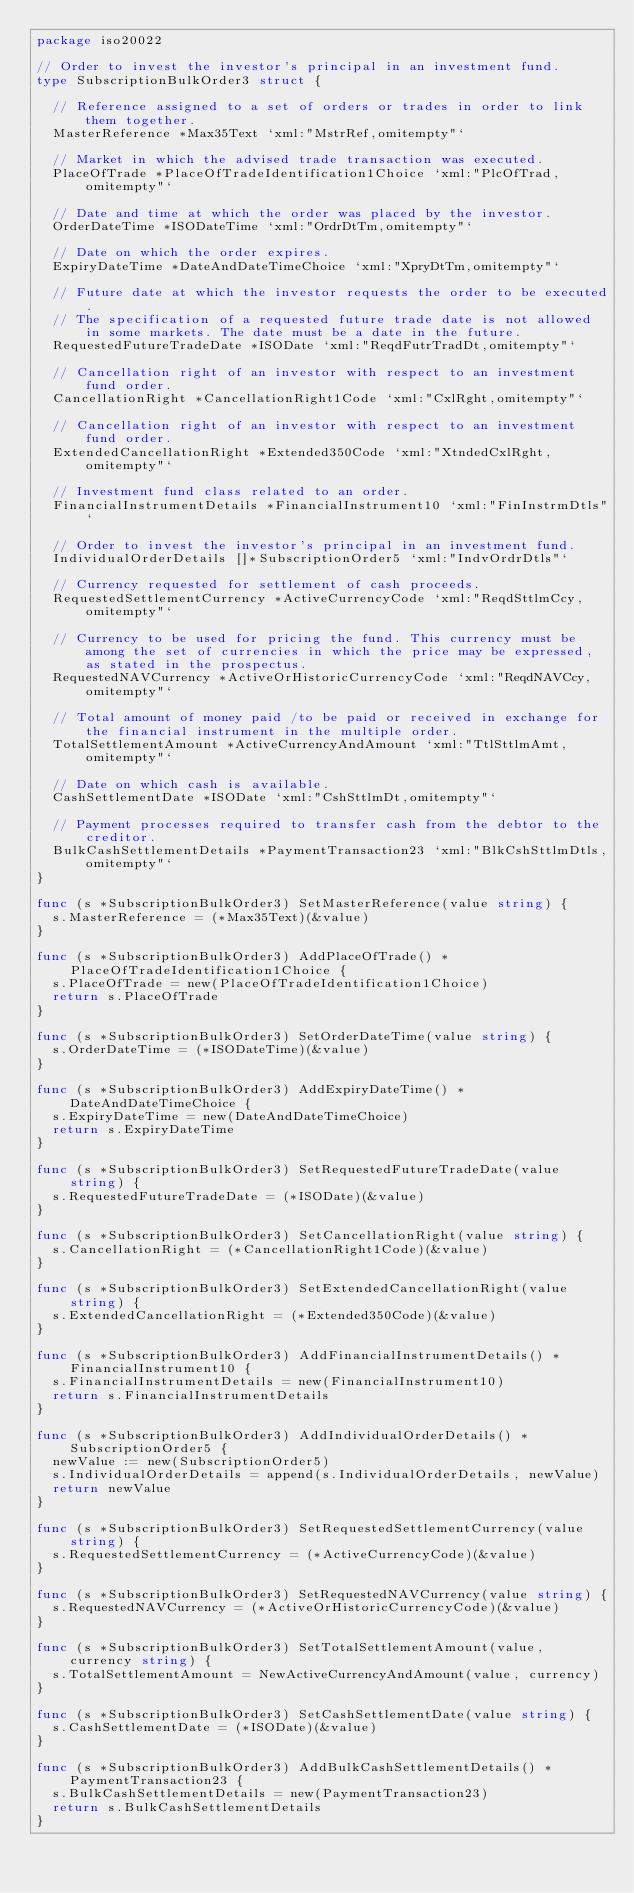<code> <loc_0><loc_0><loc_500><loc_500><_Go_>package iso20022

// Order to invest the investor's principal in an investment fund.
type SubscriptionBulkOrder3 struct {

	// Reference assigned to a set of orders or trades in order to link them together.
	MasterReference *Max35Text `xml:"MstrRef,omitempty"`

	// Market in which the advised trade transaction was executed.
	PlaceOfTrade *PlaceOfTradeIdentification1Choice `xml:"PlcOfTrad,omitempty"`

	// Date and time at which the order was placed by the investor.
	OrderDateTime *ISODateTime `xml:"OrdrDtTm,omitempty"`

	// Date on which the order expires.
	ExpiryDateTime *DateAndDateTimeChoice `xml:"XpryDtTm,omitempty"`

	// Future date at which the investor requests the order to be executed.
	// The specification of a requested future trade date is not allowed in some markets. The date must be a date in the future.
	RequestedFutureTradeDate *ISODate `xml:"ReqdFutrTradDt,omitempty"`

	// Cancellation right of an investor with respect to an investment fund order.
	CancellationRight *CancellationRight1Code `xml:"CxlRght,omitempty"`

	// Cancellation right of an investor with respect to an investment fund order.
	ExtendedCancellationRight *Extended350Code `xml:"XtndedCxlRght,omitempty"`

	// Investment fund class related to an order.
	FinancialInstrumentDetails *FinancialInstrument10 `xml:"FinInstrmDtls"`

	// Order to invest the investor's principal in an investment fund.
	IndividualOrderDetails []*SubscriptionOrder5 `xml:"IndvOrdrDtls"`

	// Currency requested for settlement of cash proceeds.
	RequestedSettlementCurrency *ActiveCurrencyCode `xml:"ReqdSttlmCcy,omitempty"`

	// Currency to be used for pricing the fund. This currency must be among the set of currencies in which the price may be expressed, as stated in the prospectus.
	RequestedNAVCurrency *ActiveOrHistoricCurrencyCode `xml:"ReqdNAVCcy,omitempty"`

	// Total amount of money paid /to be paid or received in exchange for the financial instrument in the multiple order.
	TotalSettlementAmount *ActiveCurrencyAndAmount `xml:"TtlSttlmAmt,omitempty"`

	// Date on which cash is available.
	CashSettlementDate *ISODate `xml:"CshSttlmDt,omitempty"`

	// Payment processes required to transfer cash from the debtor to the creditor.
	BulkCashSettlementDetails *PaymentTransaction23 `xml:"BlkCshSttlmDtls,omitempty"`
}

func (s *SubscriptionBulkOrder3) SetMasterReference(value string) {
	s.MasterReference = (*Max35Text)(&value)
}

func (s *SubscriptionBulkOrder3) AddPlaceOfTrade() *PlaceOfTradeIdentification1Choice {
	s.PlaceOfTrade = new(PlaceOfTradeIdentification1Choice)
	return s.PlaceOfTrade
}

func (s *SubscriptionBulkOrder3) SetOrderDateTime(value string) {
	s.OrderDateTime = (*ISODateTime)(&value)
}

func (s *SubscriptionBulkOrder3) AddExpiryDateTime() *DateAndDateTimeChoice {
	s.ExpiryDateTime = new(DateAndDateTimeChoice)
	return s.ExpiryDateTime
}

func (s *SubscriptionBulkOrder3) SetRequestedFutureTradeDate(value string) {
	s.RequestedFutureTradeDate = (*ISODate)(&value)
}

func (s *SubscriptionBulkOrder3) SetCancellationRight(value string) {
	s.CancellationRight = (*CancellationRight1Code)(&value)
}

func (s *SubscriptionBulkOrder3) SetExtendedCancellationRight(value string) {
	s.ExtendedCancellationRight = (*Extended350Code)(&value)
}

func (s *SubscriptionBulkOrder3) AddFinancialInstrumentDetails() *FinancialInstrument10 {
	s.FinancialInstrumentDetails = new(FinancialInstrument10)
	return s.FinancialInstrumentDetails
}

func (s *SubscriptionBulkOrder3) AddIndividualOrderDetails() *SubscriptionOrder5 {
	newValue := new(SubscriptionOrder5)
	s.IndividualOrderDetails = append(s.IndividualOrderDetails, newValue)
	return newValue
}

func (s *SubscriptionBulkOrder3) SetRequestedSettlementCurrency(value string) {
	s.RequestedSettlementCurrency = (*ActiveCurrencyCode)(&value)
}

func (s *SubscriptionBulkOrder3) SetRequestedNAVCurrency(value string) {
	s.RequestedNAVCurrency = (*ActiveOrHistoricCurrencyCode)(&value)
}

func (s *SubscriptionBulkOrder3) SetTotalSettlementAmount(value, currency string) {
	s.TotalSettlementAmount = NewActiveCurrencyAndAmount(value, currency)
}

func (s *SubscriptionBulkOrder3) SetCashSettlementDate(value string) {
	s.CashSettlementDate = (*ISODate)(&value)
}

func (s *SubscriptionBulkOrder3) AddBulkCashSettlementDetails() *PaymentTransaction23 {
	s.BulkCashSettlementDetails = new(PaymentTransaction23)
	return s.BulkCashSettlementDetails
}
</code> 